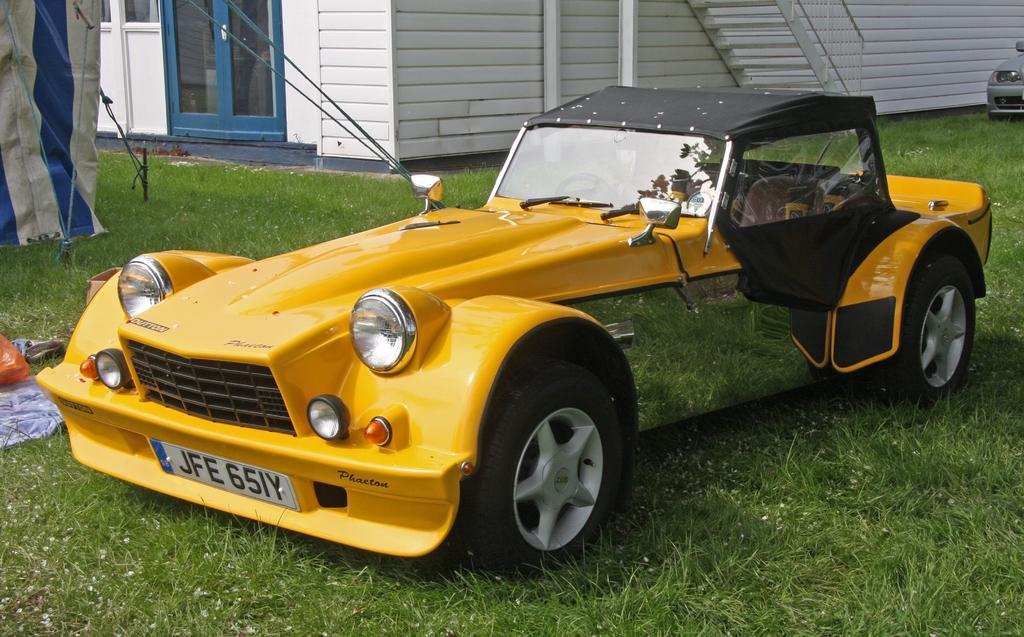What can be seen on the ground in the image? There are vehicles on the ground in the image. What structure can be seen in the background of the image? There is a shed visible in the background of the image. What else can be seen in the background of the image besides the shed? There are some objects present in the background of the image. Can you see a badge on any of the vehicles in the image? There is no mention of a badge on any of the vehicles in the image, so it cannot be confirmed or denied. What type of rest is available for the vehicles in the image? The image does not provide information about the vehicles' rest, as it only shows them on the ground. 